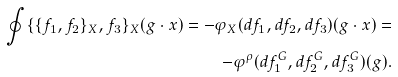<formula> <loc_0><loc_0><loc_500><loc_500>\oint \{ \{ f _ { 1 } , f _ { 2 } \} _ { X } , f _ { 3 } \} _ { X } ( g \cdot x ) = - \varphi _ { X } ( d f _ { 1 } , d f _ { 2 } , d f _ { 3 } ) ( g \cdot x ) = \\ - \varphi ^ { \rho } ( d f _ { 1 } ^ { G } , d f _ { 2 } ^ { G } , d f _ { 3 } ^ { G } ) ( g ) .</formula> 